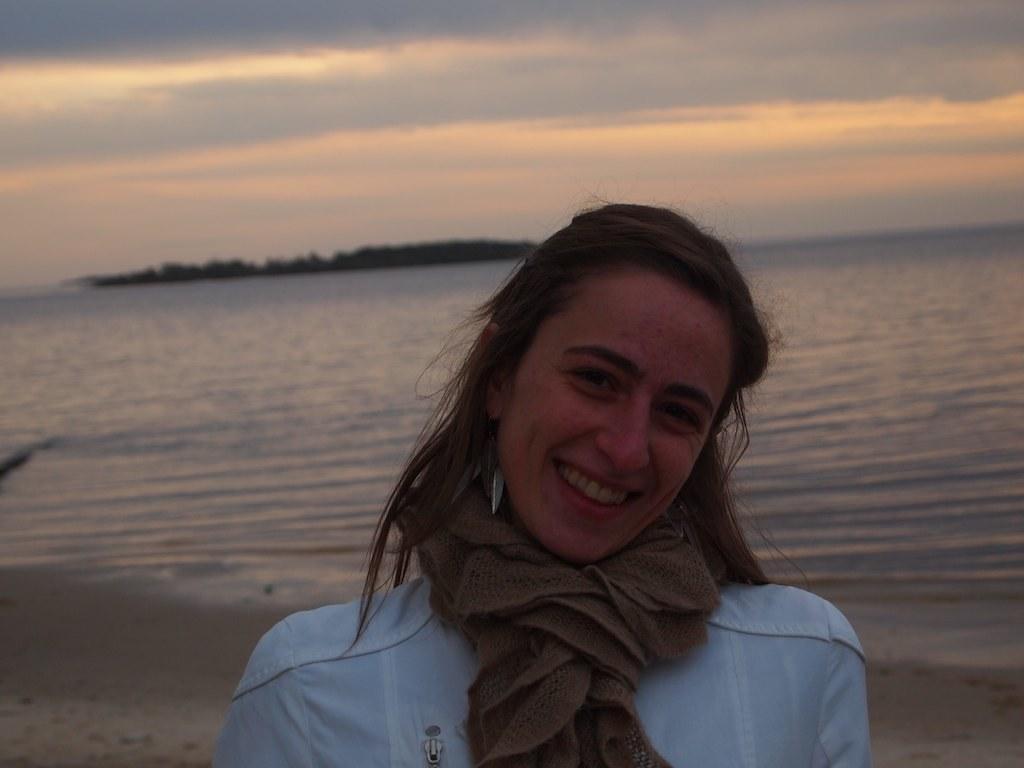Please provide a concise description of this image. In this image in the foreground there is one woman who is wearing a scarf and white dress and she is smiling, and in the background there is sand beach and trees. At the top there is sky. 